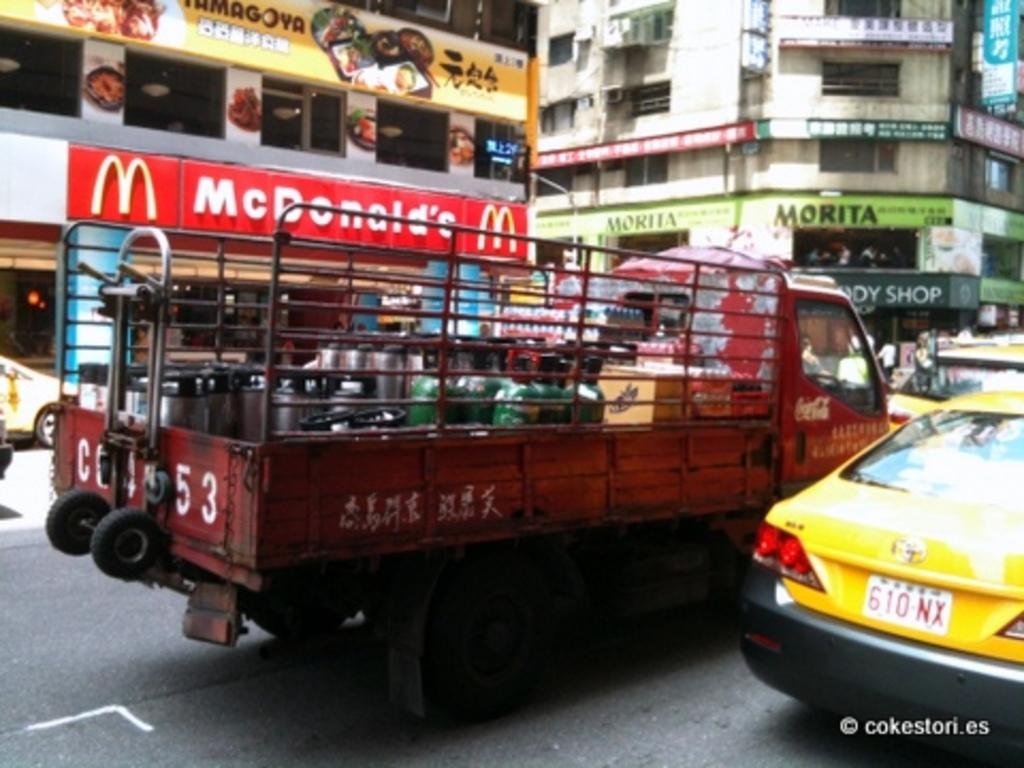<image>
Offer a succinct explanation of the picture presented. A red truck is on a busy street in front of a McDonald's. 